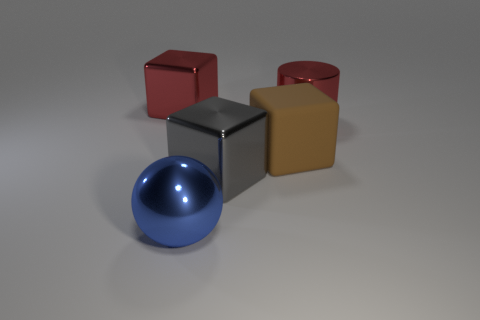Are there more large gray blocks that are behind the big shiny cylinder than large rubber blocks behind the big brown rubber object?
Your response must be concise. No. Do the cylinder and the sphere have the same size?
Your response must be concise. Yes. The rubber thing that is the same shape as the big gray metal thing is what color?
Your response must be concise. Brown. How many large matte blocks are the same color as the large metallic sphere?
Your answer should be very brief. 0. Is the number of gray objects that are to the left of the big gray metallic thing greater than the number of small gray rubber cylinders?
Your answer should be very brief. No. There is a cube that is behind the big red shiny object right of the brown cube; what is its color?
Keep it short and to the point. Red. How many things are either big gray things that are on the left side of the large rubber cube or objects on the left side of the gray block?
Ensure brevity in your answer.  3. The shiny cylinder has what color?
Keep it short and to the point. Red. How many other cylinders are the same material as the cylinder?
Your answer should be very brief. 0. Are there more large spheres than purple rubber cylinders?
Offer a very short reply. Yes. 